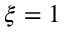Convert formula to latex. <formula><loc_0><loc_0><loc_500><loc_500>\xi = 1</formula> 